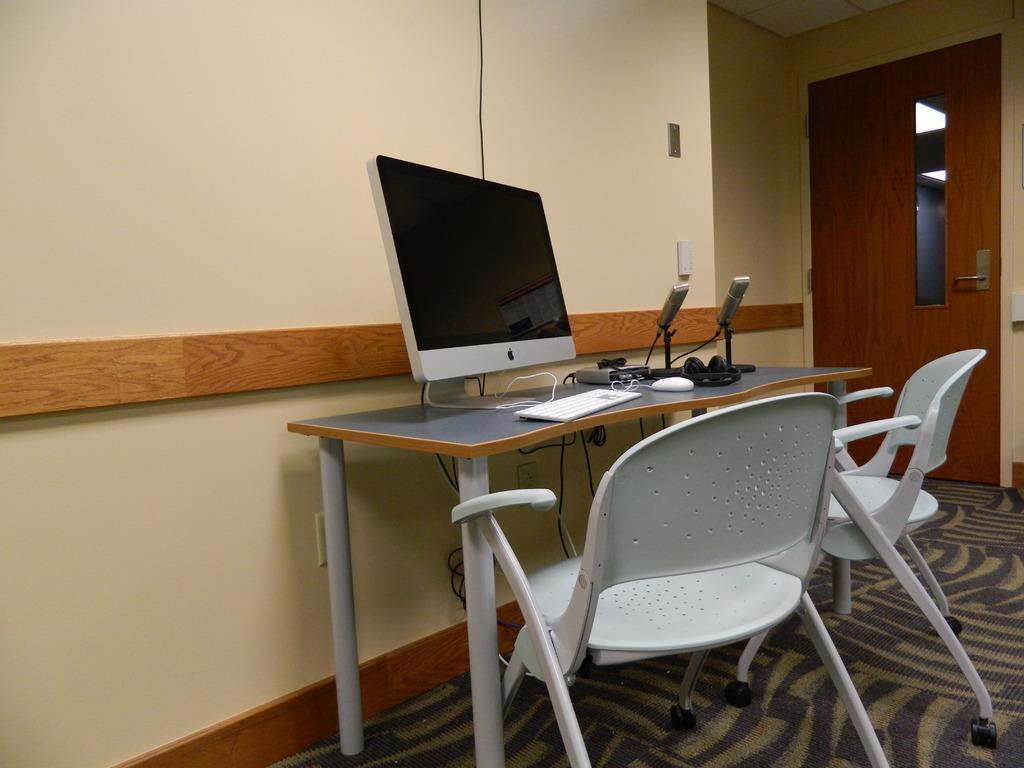Could you give a brief overview of what you see in this image? In this image we can see few objects on a table and there are two chairs on the floor. Behind the table, we can see a wall and on the right side of the image we can see a door with the glass. 